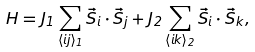<formula> <loc_0><loc_0><loc_500><loc_500>H = J _ { 1 } \sum _ { \langle i j \rangle _ { 1 } } \vec { S } _ { i } \cdot \vec { S } _ { j } + J _ { 2 } \sum _ { \langle i k \rangle _ { 2 } } \vec { S } _ { i } \cdot \vec { S } _ { k } ,</formula> 